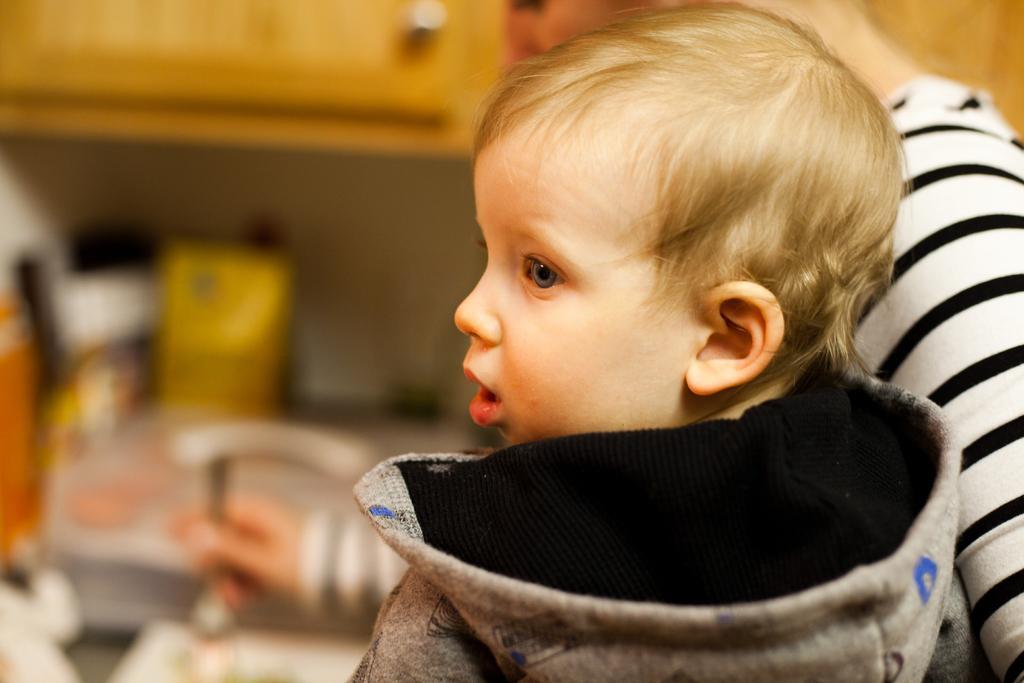Describe this image in one or two sentences. In this image we can see a kid and a lady. In the background there is a cupboard and we can see some objects. 